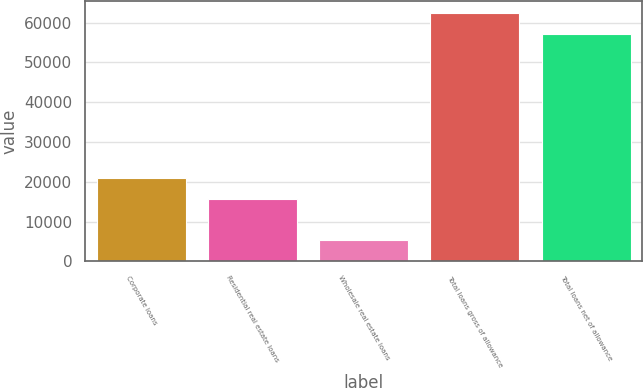<chart> <loc_0><loc_0><loc_500><loc_500><bar_chart><fcel>Corporate loans<fcel>Residential real estate loans<fcel>Wholesale real estate loans<fcel>Total loans gross of allowance<fcel>Total loans net of allowance<nl><fcel>20932<fcel>15735<fcel>5298<fcel>62316<fcel>57119<nl></chart> 